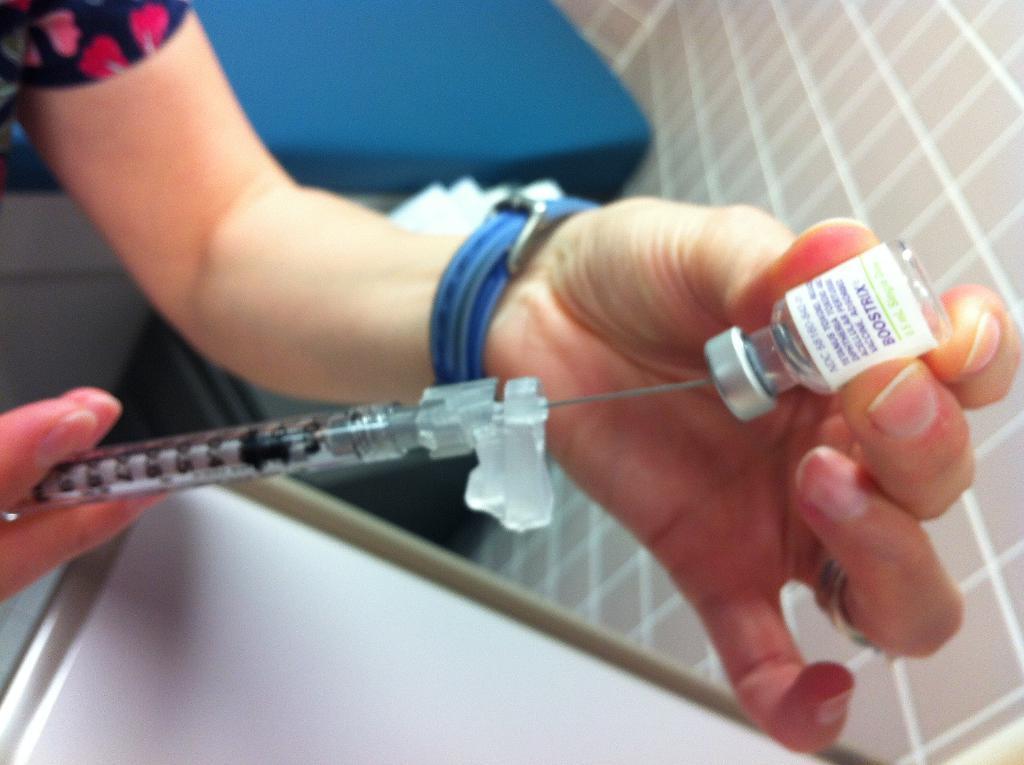Could you give a brief overview of what you see in this image? In this image, we can see a person holding a syringe and a bottle. In the background, there are some objects. 